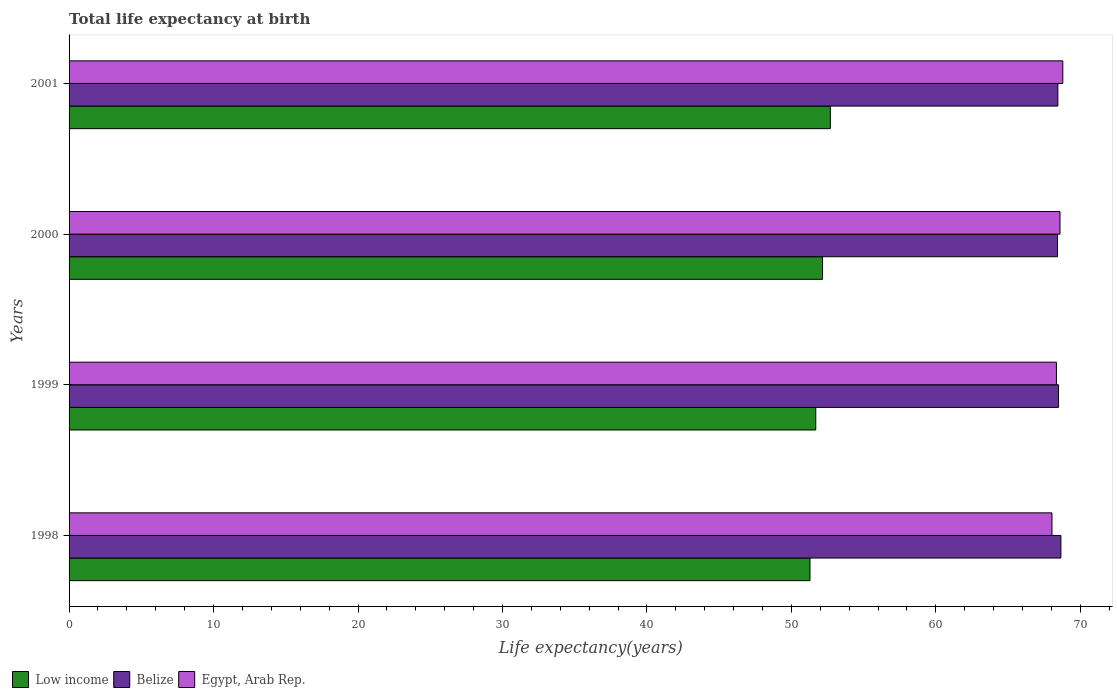How many different coloured bars are there?
Ensure brevity in your answer.  3. How many groups of bars are there?
Give a very brief answer. 4. Are the number of bars on each tick of the Y-axis equal?
Provide a short and direct response. Yes. How many bars are there on the 3rd tick from the top?
Provide a short and direct response. 3. What is the label of the 3rd group of bars from the top?
Offer a terse response. 1999. In how many cases, is the number of bars for a given year not equal to the number of legend labels?
Your response must be concise. 0. What is the life expectancy at birth in in Egypt, Arab Rep. in 2001?
Your answer should be very brief. 68.79. Across all years, what is the maximum life expectancy at birth in in Egypt, Arab Rep.?
Make the answer very short. 68.79. Across all years, what is the minimum life expectancy at birth in in Low income?
Your answer should be compact. 51.29. In which year was the life expectancy at birth in in Belize maximum?
Offer a terse response. 1998. What is the total life expectancy at birth in in Belize in the graph?
Provide a succinct answer. 274.01. What is the difference between the life expectancy at birth in in Low income in 1999 and that in 2000?
Provide a succinct answer. -0.47. What is the difference between the life expectancy at birth in in Low income in 2000 and the life expectancy at birth in in Egypt, Arab Rep. in 1998?
Make the answer very short. -15.88. What is the average life expectancy at birth in in Egypt, Arab Rep. per year?
Provide a succinct answer. 68.44. In the year 1998, what is the difference between the life expectancy at birth in in Egypt, Arab Rep. and life expectancy at birth in in Belize?
Offer a very short reply. -0.62. In how many years, is the life expectancy at birth in in Egypt, Arab Rep. greater than 36 years?
Your answer should be very brief. 4. What is the ratio of the life expectancy at birth in in Egypt, Arab Rep. in 1998 to that in 2000?
Your response must be concise. 0.99. What is the difference between the highest and the second highest life expectancy at birth in in Belize?
Provide a short and direct response. 0.16. What is the difference between the highest and the lowest life expectancy at birth in in Belize?
Provide a succinct answer. 0.24. Is the sum of the life expectancy at birth in in Egypt, Arab Rep. in 1998 and 1999 greater than the maximum life expectancy at birth in in Belize across all years?
Your answer should be very brief. Yes. What does the 1st bar from the top in 1998 represents?
Make the answer very short. Egypt, Arab Rep. Is it the case that in every year, the sum of the life expectancy at birth in in Low income and life expectancy at birth in in Egypt, Arab Rep. is greater than the life expectancy at birth in in Belize?
Offer a very short reply. Yes. How many bars are there?
Your answer should be compact. 12. How many years are there in the graph?
Offer a terse response. 4. What is the difference between two consecutive major ticks on the X-axis?
Give a very brief answer. 10. Are the values on the major ticks of X-axis written in scientific E-notation?
Your response must be concise. No. Does the graph contain any zero values?
Provide a short and direct response. No. Does the graph contain grids?
Make the answer very short. No. Where does the legend appear in the graph?
Make the answer very short. Bottom left. How are the legend labels stacked?
Provide a short and direct response. Horizontal. What is the title of the graph?
Keep it short and to the point. Total life expectancy at birth. What is the label or title of the X-axis?
Offer a very short reply. Life expectancy(years). What is the Life expectancy(years) in Low income in 1998?
Provide a succinct answer. 51.29. What is the Life expectancy(years) in Belize in 1998?
Your answer should be very brief. 68.65. What is the Life expectancy(years) in Egypt, Arab Rep. in 1998?
Make the answer very short. 68.04. What is the Life expectancy(years) of Low income in 1999?
Give a very brief answer. 51.69. What is the Life expectancy(years) in Belize in 1999?
Your answer should be very brief. 68.49. What is the Life expectancy(years) in Egypt, Arab Rep. in 1999?
Offer a terse response. 68.35. What is the Life expectancy(years) in Low income in 2000?
Give a very brief answer. 52.16. What is the Life expectancy(years) in Belize in 2000?
Ensure brevity in your answer.  68.42. What is the Life expectancy(years) of Egypt, Arab Rep. in 2000?
Your response must be concise. 68.59. What is the Life expectancy(years) of Low income in 2001?
Make the answer very short. 52.7. What is the Life expectancy(years) in Belize in 2001?
Make the answer very short. 68.44. What is the Life expectancy(years) of Egypt, Arab Rep. in 2001?
Provide a succinct answer. 68.79. Across all years, what is the maximum Life expectancy(years) of Low income?
Your response must be concise. 52.7. Across all years, what is the maximum Life expectancy(years) of Belize?
Offer a very short reply. 68.65. Across all years, what is the maximum Life expectancy(years) in Egypt, Arab Rep.?
Your answer should be very brief. 68.79. Across all years, what is the minimum Life expectancy(years) of Low income?
Keep it short and to the point. 51.29. Across all years, what is the minimum Life expectancy(years) of Belize?
Provide a short and direct response. 68.42. Across all years, what is the minimum Life expectancy(years) of Egypt, Arab Rep.?
Offer a terse response. 68.04. What is the total Life expectancy(years) in Low income in the graph?
Your answer should be very brief. 207.82. What is the total Life expectancy(years) of Belize in the graph?
Make the answer very short. 274.01. What is the total Life expectancy(years) in Egypt, Arab Rep. in the graph?
Keep it short and to the point. 273.76. What is the difference between the Life expectancy(years) in Low income in 1998 and that in 1999?
Offer a very short reply. -0.4. What is the difference between the Life expectancy(years) of Belize in 1998 and that in 1999?
Ensure brevity in your answer.  0.16. What is the difference between the Life expectancy(years) of Egypt, Arab Rep. in 1998 and that in 1999?
Provide a succinct answer. -0.31. What is the difference between the Life expectancy(years) in Low income in 1998 and that in 2000?
Make the answer very short. -0.87. What is the difference between the Life expectancy(years) of Belize in 1998 and that in 2000?
Offer a very short reply. 0.23. What is the difference between the Life expectancy(years) of Egypt, Arab Rep. in 1998 and that in 2000?
Provide a short and direct response. -0.55. What is the difference between the Life expectancy(years) of Low income in 1998 and that in 2001?
Provide a short and direct response. -1.41. What is the difference between the Life expectancy(years) of Belize in 1998 and that in 2001?
Keep it short and to the point. 0.21. What is the difference between the Life expectancy(years) in Egypt, Arab Rep. in 1998 and that in 2001?
Your response must be concise. -0.75. What is the difference between the Life expectancy(years) in Low income in 1999 and that in 2000?
Your response must be concise. -0.47. What is the difference between the Life expectancy(years) of Belize in 1999 and that in 2000?
Provide a short and direct response. 0.07. What is the difference between the Life expectancy(years) of Egypt, Arab Rep. in 1999 and that in 2000?
Offer a very short reply. -0.25. What is the difference between the Life expectancy(years) of Low income in 1999 and that in 2001?
Ensure brevity in your answer.  -1.01. What is the difference between the Life expectancy(years) of Belize in 1999 and that in 2001?
Give a very brief answer. 0.05. What is the difference between the Life expectancy(years) of Egypt, Arab Rep. in 1999 and that in 2001?
Make the answer very short. -0.44. What is the difference between the Life expectancy(years) of Low income in 2000 and that in 2001?
Your answer should be compact. -0.54. What is the difference between the Life expectancy(years) of Belize in 2000 and that in 2001?
Offer a very short reply. -0.03. What is the difference between the Life expectancy(years) of Egypt, Arab Rep. in 2000 and that in 2001?
Keep it short and to the point. -0.2. What is the difference between the Life expectancy(years) in Low income in 1998 and the Life expectancy(years) in Belize in 1999?
Provide a succinct answer. -17.2. What is the difference between the Life expectancy(years) in Low income in 1998 and the Life expectancy(years) in Egypt, Arab Rep. in 1999?
Provide a short and direct response. -17.06. What is the difference between the Life expectancy(years) of Belize in 1998 and the Life expectancy(years) of Egypt, Arab Rep. in 1999?
Ensure brevity in your answer.  0.31. What is the difference between the Life expectancy(years) of Low income in 1998 and the Life expectancy(years) of Belize in 2000?
Your answer should be very brief. -17.13. What is the difference between the Life expectancy(years) in Low income in 1998 and the Life expectancy(years) in Egypt, Arab Rep. in 2000?
Offer a terse response. -17.3. What is the difference between the Life expectancy(years) in Belize in 1998 and the Life expectancy(years) in Egypt, Arab Rep. in 2000?
Your answer should be compact. 0.06. What is the difference between the Life expectancy(years) in Low income in 1998 and the Life expectancy(years) in Belize in 2001?
Make the answer very short. -17.16. What is the difference between the Life expectancy(years) in Low income in 1998 and the Life expectancy(years) in Egypt, Arab Rep. in 2001?
Provide a short and direct response. -17.5. What is the difference between the Life expectancy(years) in Belize in 1998 and the Life expectancy(years) in Egypt, Arab Rep. in 2001?
Your answer should be very brief. -0.13. What is the difference between the Life expectancy(years) in Low income in 1999 and the Life expectancy(years) in Belize in 2000?
Provide a short and direct response. -16.73. What is the difference between the Life expectancy(years) of Low income in 1999 and the Life expectancy(years) of Egypt, Arab Rep. in 2000?
Ensure brevity in your answer.  -16.9. What is the difference between the Life expectancy(years) of Belize in 1999 and the Life expectancy(years) of Egypt, Arab Rep. in 2000?
Provide a succinct answer. -0.1. What is the difference between the Life expectancy(years) of Low income in 1999 and the Life expectancy(years) of Belize in 2001?
Keep it short and to the point. -16.76. What is the difference between the Life expectancy(years) in Low income in 1999 and the Life expectancy(years) in Egypt, Arab Rep. in 2001?
Your response must be concise. -17.1. What is the difference between the Life expectancy(years) in Belize in 1999 and the Life expectancy(years) in Egypt, Arab Rep. in 2001?
Your answer should be compact. -0.3. What is the difference between the Life expectancy(years) in Low income in 2000 and the Life expectancy(years) in Belize in 2001?
Provide a short and direct response. -16.29. What is the difference between the Life expectancy(years) in Low income in 2000 and the Life expectancy(years) in Egypt, Arab Rep. in 2001?
Keep it short and to the point. -16.63. What is the difference between the Life expectancy(years) in Belize in 2000 and the Life expectancy(years) in Egypt, Arab Rep. in 2001?
Your answer should be very brief. -0.37. What is the average Life expectancy(years) in Low income per year?
Make the answer very short. 51.96. What is the average Life expectancy(years) of Belize per year?
Your response must be concise. 68.5. What is the average Life expectancy(years) of Egypt, Arab Rep. per year?
Your answer should be very brief. 68.44. In the year 1998, what is the difference between the Life expectancy(years) in Low income and Life expectancy(years) in Belize?
Offer a terse response. -17.37. In the year 1998, what is the difference between the Life expectancy(years) of Low income and Life expectancy(years) of Egypt, Arab Rep.?
Give a very brief answer. -16.75. In the year 1998, what is the difference between the Life expectancy(years) of Belize and Life expectancy(years) of Egypt, Arab Rep.?
Offer a very short reply. 0.62. In the year 1999, what is the difference between the Life expectancy(years) of Low income and Life expectancy(years) of Belize?
Offer a very short reply. -16.8. In the year 1999, what is the difference between the Life expectancy(years) in Low income and Life expectancy(years) in Egypt, Arab Rep.?
Provide a short and direct response. -16.66. In the year 1999, what is the difference between the Life expectancy(years) of Belize and Life expectancy(years) of Egypt, Arab Rep.?
Provide a short and direct response. 0.14. In the year 2000, what is the difference between the Life expectancy(years) in Low income and Life expectancy(years) in Belize?
Offer a terse response. -16.26. In the year 2000, what is the difference between the Life expectancy(years) of Low income and Life expectancy(years) of Egypt, Arab Rep.?
Ensure brevity in your answer.  -16.44. In the year 2000, what is the difference between the Life expectancy(years) of Belize and Life expectancy(years) of Egypt, Arab Rep.?
Provide a short and direct response. -0.17. In the year 2001, what is the difference between the Life expectancy(years) of Low income and Life expectancy(years) of Belize?
Your response must be concise. -15.75. In the year 2001, what is the difference between the Life expectancy(years) in Low income and Life expectancy(years) in Egypt, Arab Rep.?
Offer a terse response. -16.09. In the year 2001, what is the difference between the Life expectancy(years) in Belize and Life expectancy(years) in Egypt, Arab Rep.?
Your answer should be compact. -0.34. What is the ratio of the Life expectancy(years) in Low income in 1998 to that in 2000?
Offer a very short reply. 0.98. What is the ratio of the Life expectancy(years) in Belize in 1998 to that in 2000?
Make the answer very short. 1. What is the ratio of the Life expectancy(years) in Egypt, Arab Rep. in 1998 to that in 2000?
Give a very brief answer. 0.99. What is the ratio of the Life expectancy(years) in Low income in 1998 to that in 2001?
Ensure brevity in your answer.  0.97. What is the ratio of the Life expectancy(years) in Belize in 1998 to that in 2001?
Offer a terse response. 1. What is the ratio of the Life expectancy(years) in Egypt, Arab Rep. in 1998 to that in 2001?
Your answer should be very brief. 0.99. What is the ratio of the Life expectancy(years) of Egypt, Arab Rep. in 1999 to that in 2000?
Your response must be concise. 1. What is the ratio of the Life expectancy(years) in Low income in 1999 to that in 2001?
Give a very brief answer. 0.98. What is the ratio of the Life expectancy(years) in Belize in 1999 to that in 2001?
Your answer should be compact. 1. What is the ratio of the Life expectancy(years) of Belize in 2000 to that in 2001?
Offer a very short reply. 1. What is the ratio of the Life expectancy(years) of Egypt, Arab Rep. in 2000 to that in 2001?
Your answer should be compact. 1. What is the difference between the highest and the second highest Life expectancy(years) in Low income?
Offer a very short reply. 0.54. What is the difference between the highest and the second highest Life expectancy(years) of Belize?
Provide a succinct answer. 0.16. What is the difference between the highest and the second highest Life expectancy(years) of Egypt, Arab Rep.?
Keep it short and to the point. 0.2. What is the difference between the highest and the lowest Life expectancy(years) of Low income?
Give a very brief answer. 1.41. What is the difference between the highest and the lowest Life expectancy(years) in Belize?
Offer a terse response. 0.23. What is the difference between the highest and the lowest Life expectancy(years) in Egypt, Arab Rep.?
Your response must be concise. 0.75. 